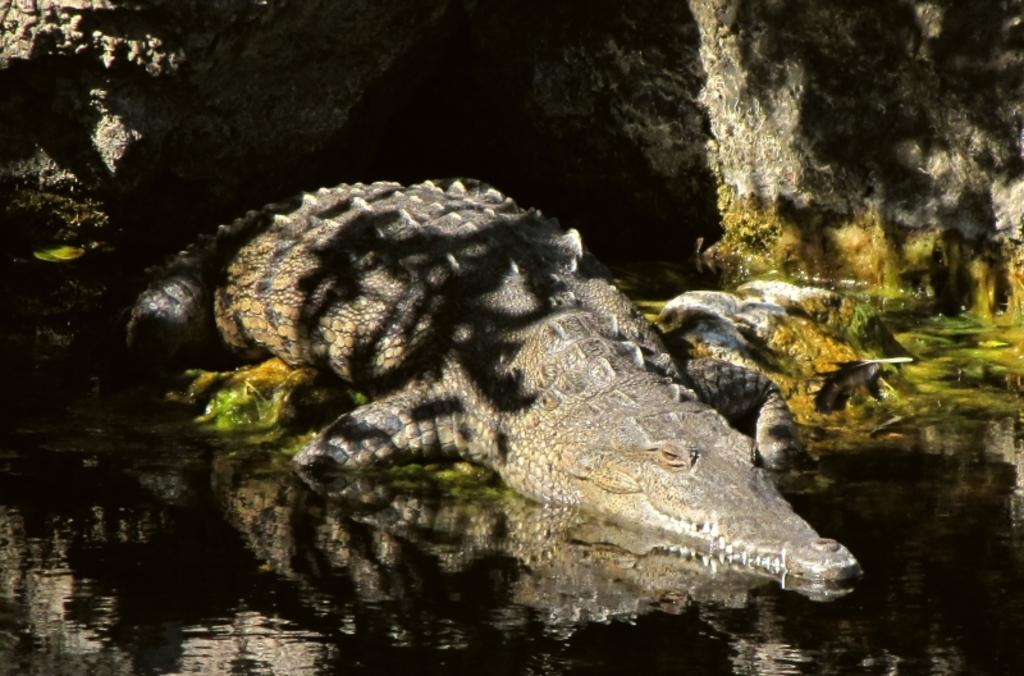What animal is present in the image? There is a crocodile in the image. Where is the crocodile located? The crocodile is on the surface of the water. What can be seen in the background of the image? There are rocks visible in the background of the image. What type of fog can be seen surrounding the cabbage in the image? There is no fog or cabbage present in the image; it features a crocodile on the surface of the water with rocks visible in the background. 